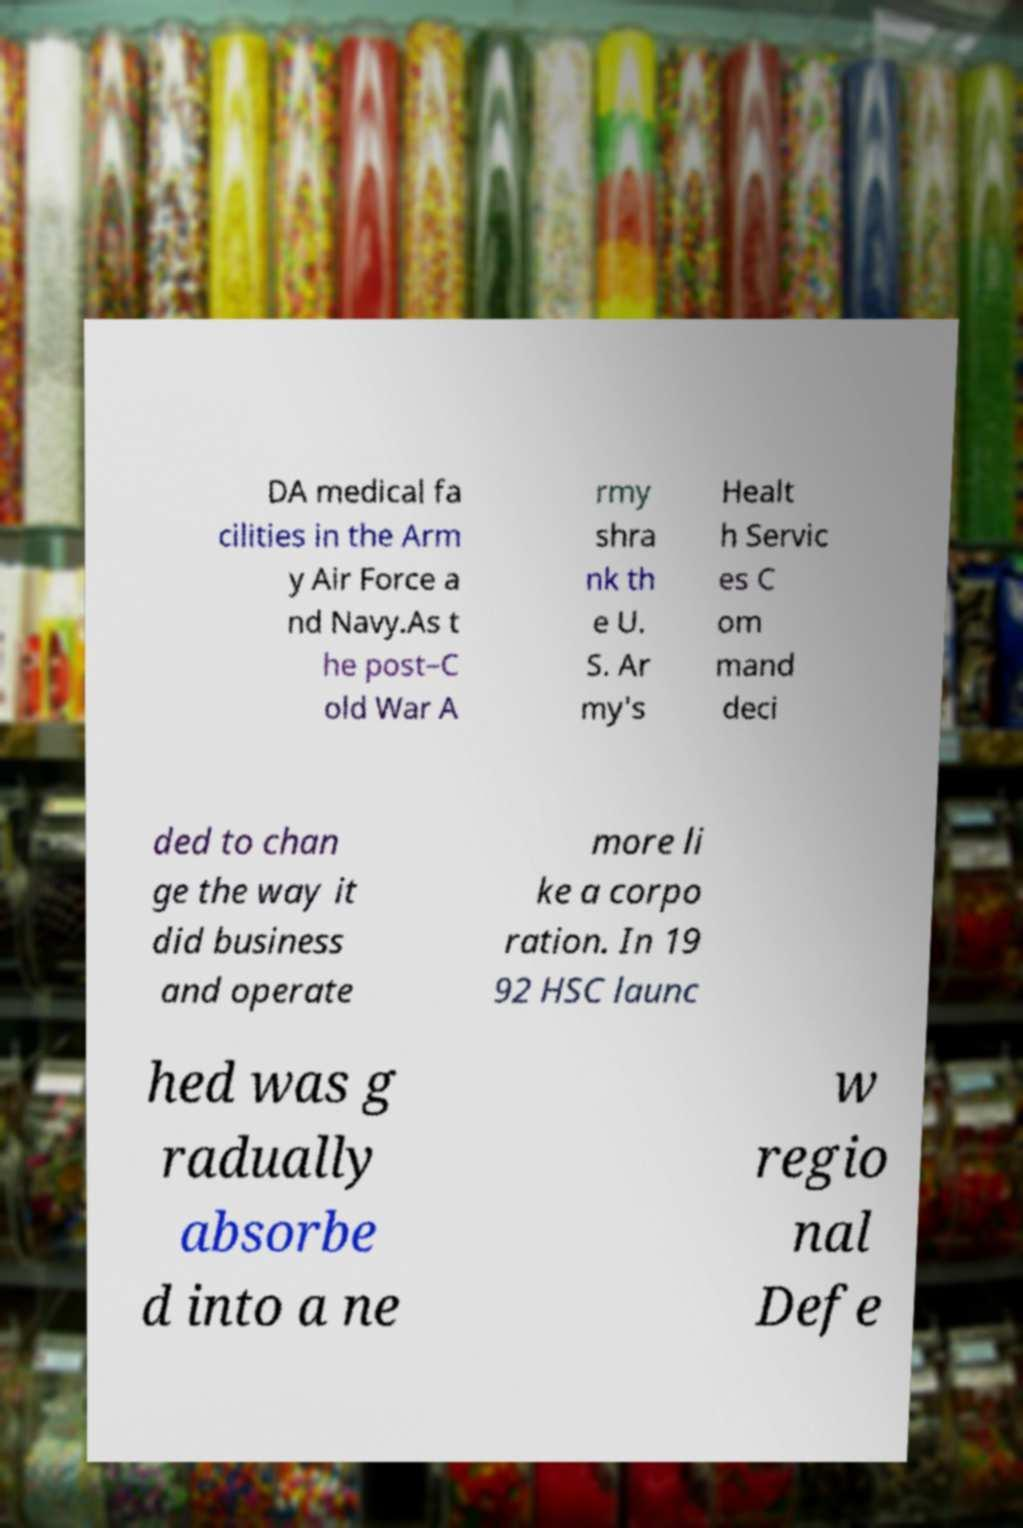What messages or text are displayed in this image? I need them in a readable, typed format. DA medical fa cilities in the Arm y Air Force a nd Navy.As t he post–C old War A rmy shra nk th e U. S. Ar my's Healt h Servic es C om mand deci ded to chan ge the way it did business and operate more li ke a corpo ration. In 19 92 HSC launc hed was g radually absorbe d into a ne w regio nal Defe 